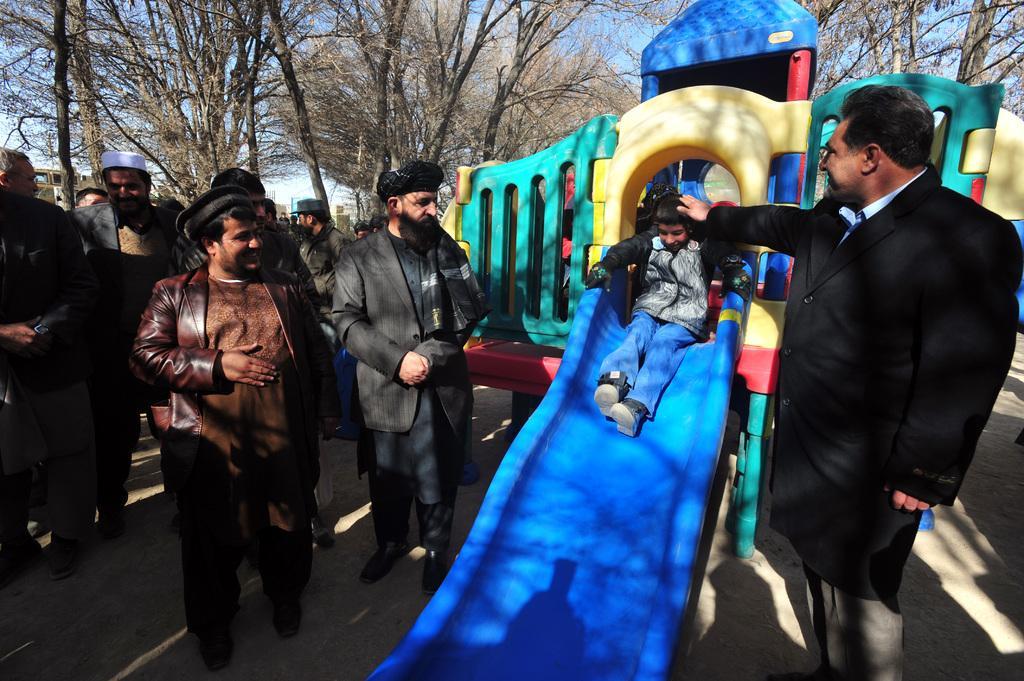What is the kid doing in the image? The kid is on a slide board in the image. Are there any other people present in the image? Yes, there are other people in the image. What type of natural elements can be seen in the image? There are trees and plants in the image. What direction is the pet moving in the image? There is no pet present in the image. What is the current status of the trees in the image? The provided facts do not give information about the current status of the trees, only that they are present in the image. 